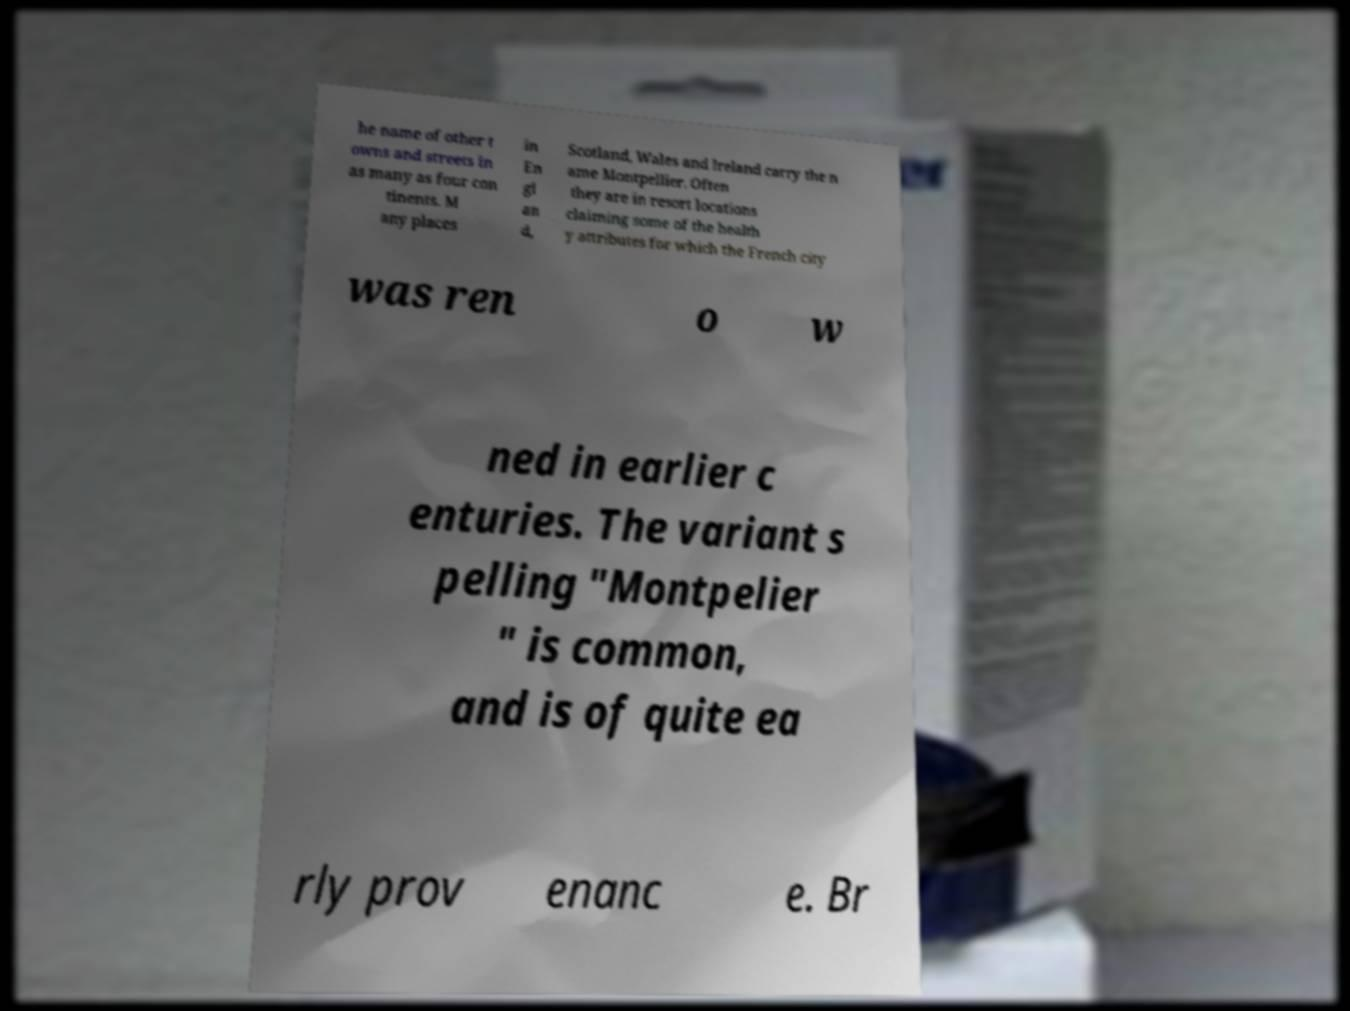I need the written content from this picture converted into text. Can you do that? he name of other t owns and streets in as many as four con tinents. M any places in En gl an d, Scotland, Wales and Ireland carry the n ame Montpellier. Often they are in resort locations claiming some of the health y attributes for which the French city was ren o w ned in earlier c enturies. The variant s pelling "Montpelier " is common, and is of quite ea rly prov enanc e. Br 